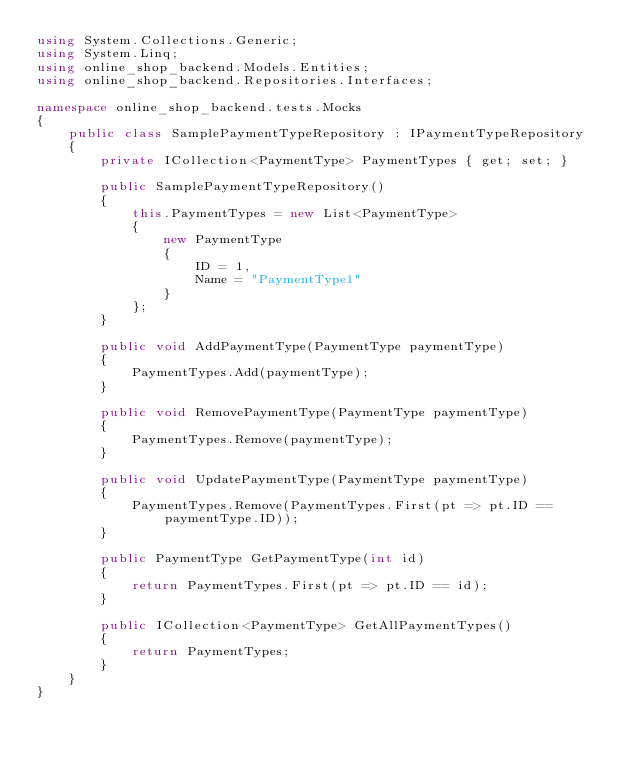<code> <loc_0><loc_0><loc_500><loc_500><_C#_>using System.Collections.Generic;
using System.Linq;
using online_shop_backend.Models.Entities;
using online_shop_backend.Repositories.Interfaces;

namespace online_shop_backend.tests.Mocks
{
    public class SamplePaymentTypeRepository : IPaymentTypeRepository
    {
        private ICollection<PaymentType> PaymentTypes { get; set; }

        public SamplePaymentTypeRepository()
        {
            this.PaymentTypes = new List<PaymentType>
            {
                new PaymentType
                {
                    ID = 1,
                    Name = "PaymentType1"
                }
            };
        }
        
        public void AddPaymentType(PaymentType paymentType)
        {
            PaymentTypes.Add(paymentType);
        }

        public void RemovePaymentType(PaymentType paymentType)
        {
            PaymentTypes.Remove(paymentType);
        }

        public void UpdatePaymentType(PaymentType paymentType)
        {
            PaymentTypes.Remove(PaymentTypes.First(pt => pt.ID == paymentType.ID));
        }

        public PaymentType GetPaymentType(int id)
        {
            return PaymentTypes.First(pt => pt.ID == id);
        }

        public ICollection<PaymentType> GetAllPaymentTypes()
        {
            return PaymentTypes;
        }
    }
}</code> 